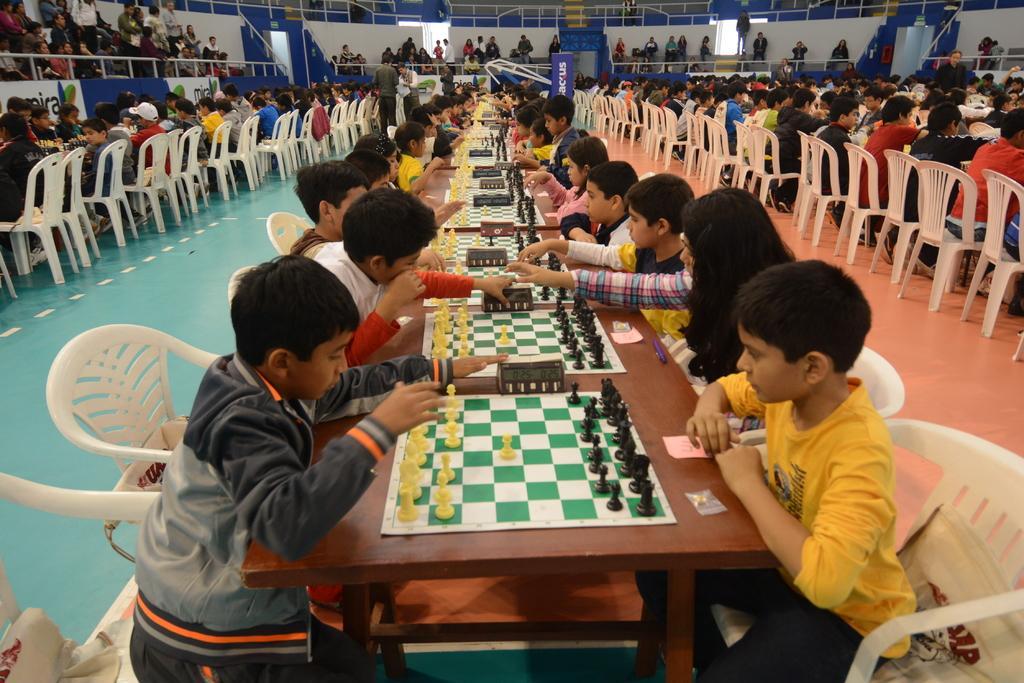In one or two sentences, can you explain what this image depicts? This is an indoor picture and it's a stadium. Here we can see all the persons sitting on chairs in front of a table and playing chess. on the table we can see pen, papers, sticky papers and chess board and pieces. This is a floor. Here we can see all the crowd standing and sitting. 